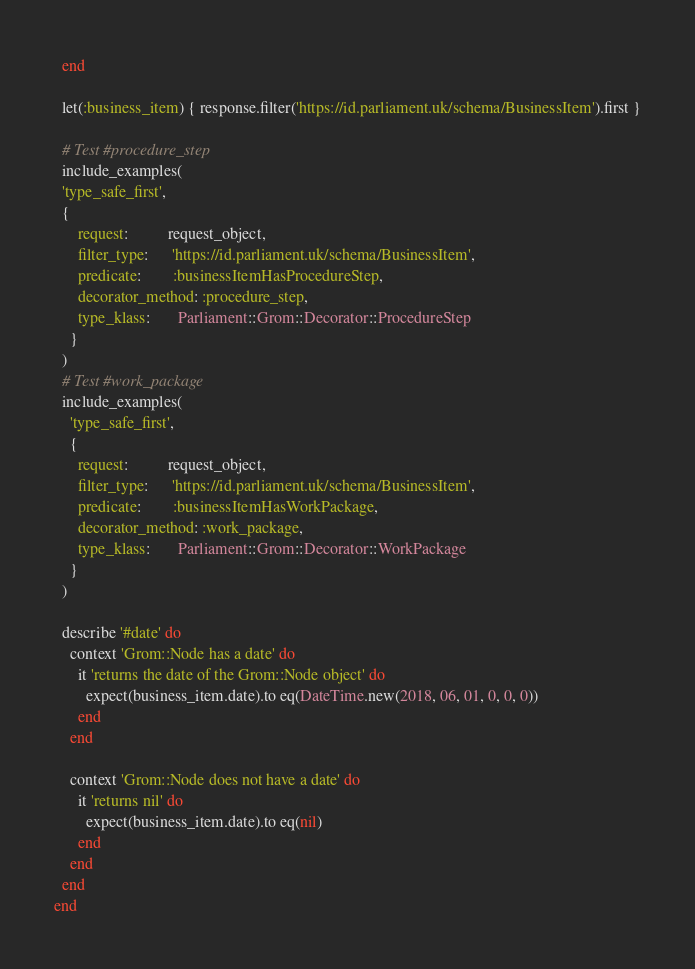Convert code to text. <code><loc_0><loc_0><loc_500><loc_500><_Ruby_>  end

  let(:business_item) { response.filter('https://id.parliament.uk/schema/BusinessItem').first }

  # Test #procedure_step
  include_examples(
  'type_safe_first',
  {
      request:          request_object,
      filter_type:      'https://id.parliament.uk/schema/BusinessItem',
      predicate:        :businessItemHasProcedureStep,
      decorator_method: :procedure_step,
      type_klass:       Parliament::Grom::Decorator::ProcedureStep
    }
  )
  # Test #work_package
  include_examples(
    'type_safe_first',
    {
      request:          request_object,
      filter_type:      'https://id.parliament.uk/schema/BusinessItem',
      predicate:        :businessItemHasWorkPackage,
      decorator_method: :work_package,
      type_klass:       Parliament::Grom::Decorator::WorkPackage
    }
  )

  describe '#date' do
    context 'Grom::Node has a date' do
      it 'returns the date of the Grom::Node object' do
        expect(business_item.date).to eq(DateTime.new(2018, 06, 01, 0, 0, 0))
      end
    end

    context 'Grom::Node does not have a date' do
      it 'returns nil' do
        expect(business_item.date).to eq(nil)
      end
    end
  end
end
</code> 